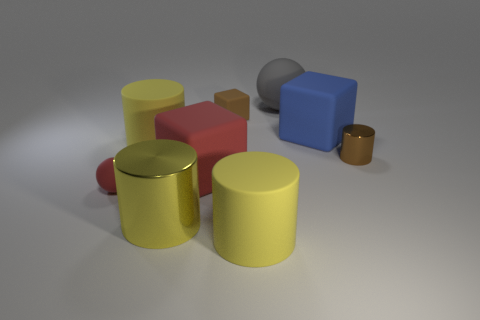There is a small cube that is the same color as the small metallic object; what is it made of?
Offer a very short reply. Rubber. Are there any rubber cylinders that have the same size as the blue matte object?
Make the answer very short. Yes. There is a big blue rubber thing; is it the same shape as the small rubber object to the right of the large red cube?
Your answer should be compact. Yes. There is a shiny thing that is behind the large red object; is its size the same as the red rubber object that is left of the yellow metallic cylinder?
Provide a succinct answer. Yes. What number of other things are the same shape as the tiny shiny thing?
Your answer should be very brief. 3. What is the material of the tiny object on the right side of the yellow cylinder that is right of the brown matte thing?
Offer a very short reply. Metal. What number of rubber objects are big blocks or large red objects?
Make the answer very short. 2. Is there anything else that has the same material as the small cylinder?
Provide a short and direct response. Yes. There is a rubber sphere to the right of the tiny brown matte object; are there any large matte blocks that are on the left side of it?
Your answer should be very brief. Yes. How many things are large rubber cylinders that are in front of the brown cylinder or small things that are in front of the blue block?
Offer a terse response. 3. 